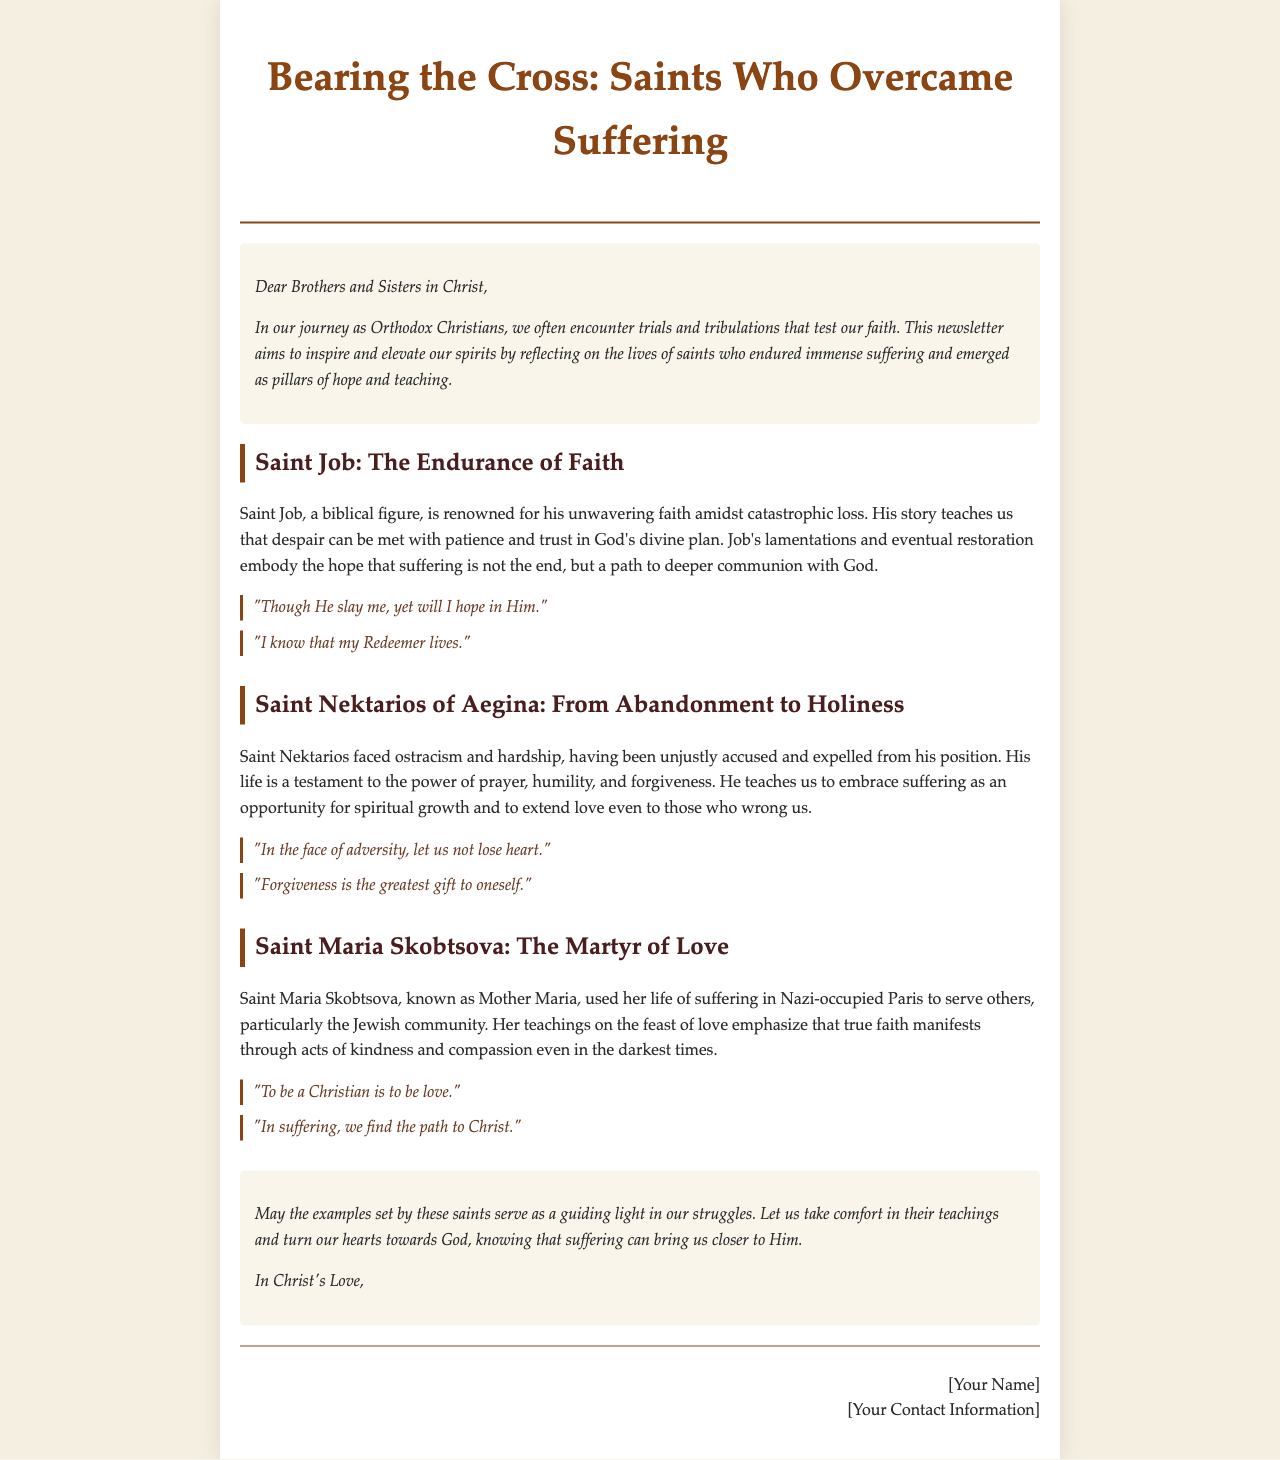What is the title of the newsletter? The title of the newsletter is prominently displayed at the top of the document.
Answer: Bearing the Cross: Saints Who Overcame Suffering Who is the first saint discussed in the newsletter? The first saint mentioned in the document is stated in the first article section.
Answer: Saint Job What does Saint Job's story teach us about suffering? The document provides a clear lesson taught through Saint Job's experiences regarding suffering.
Answer: Patience and trust in God's divine plan Which saint's life emphasizes the power of prayer and forgiveness? The document highlights a specific saint known for these qualities in one of its articles.
Answer: Saint Nektarios of Aegina What quote is attributed to Saint Maria Skobtsova? The newsletter includes notable quotes related to the teachings of the saints, including one from Saint Maria Skobtsova.
Answer: "To be a Christian is to be love." What theme does the newsletter primarily focus on? The content of the newsletter revolves around specific challenges faced by the saints and their teachings.
Answer: Overcoming suffering and despair 